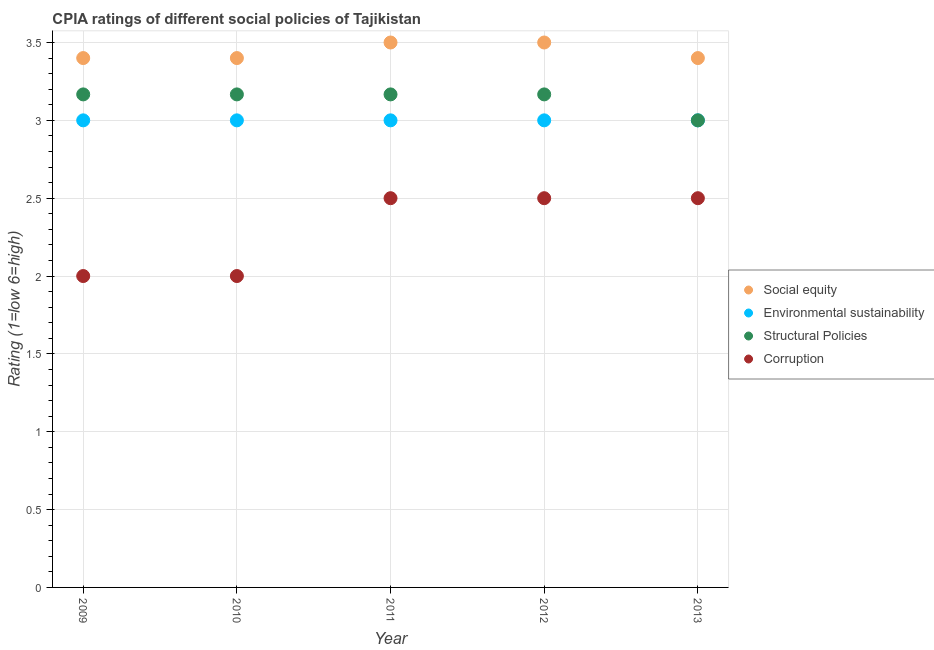How many different coloured dotlines are there?
Provide a succinct answer. 4. Is the number of dotlines equal to the number of legend labels?
Your answer should be very brief. Yes. What is the cpia rating of environmental sustainability in 2012?
Your response must be concise. 3. Across all years, what is the maximum cpia rating of structural policies?
Ensure brevity in your answer.  3.17. In which year was the cpia rating of corruption maximum?
Your response must be concise. 2011. What is the total cpia rating of structural policies in the graph?
Offer a terse response. 15.67. What is the difference between the cpia rating of environmental sustainability in 2011 and that in 2012?
Offer a very short reply. 0. What is the difference between the cpia rating of environmental sustainability in 2011 and the cpia rating of structural policies in 2010?
Offer a very short reply. -0.17. What is the average cpia rating of social equity per year?
Provide a short and direct response. 3.44. In the year 2011, what is the difference between the cpia rating of structural policies and cpia rating of social equity?
Your response must be concise. -0.33. Is the difference between the cpia rating of social equity in 2011 and 2012 greater than the difference between the cpia rating of corruption in 2011 and 2012?
Your answer should be very brief. No. What is the difference between the highest and the lowest cpia rating of environmental sustainability?
Make the answer very short. 0. In how many years, is the cpia rating of social equity greater than the average cpia rating of social equity taken over all years?
Give a very brief answer. 2. Is it the case that in every year, the sum of the cpia rating of social equity and cpia rating of environmental sustainability is greater than the cpia rating of structural policies?
Provide a succinct answer. Yes. How many dotlines are there?
Provide a short and direct response. 4. How many years are there in the graph?
Keep it short and to the point. 5. Are the values on the major ticks of Y-axis written in scientific E-notation?
Ensure brevity in your answer.  No. Does the graph contain any zero values?
Offer a terse response. No. How many legend labels are there?
Keep it short and to the point. 4. How are the legend labels stacked?
Your response must be concise. Vertical. What is the title of the graph?
Provide a short and direct response. CPIA ratings of different social policies of Tajikistan. What is the label or title of the X-axis?
Ensure brevity in your answer.  Year. What is the Rating (1=low 6=high) of Social equity in 2009?
Ensure brevity in your answer.  3.4. What is the Rating (1=low 6=high) in Structural Policies in 2009?
Offer a very short reply. 3.17. What is the Rating (1=low 6=high) in Corruption in 2009?
Offer a terse response. 2. What is the Rating (1=low 6=high) in Structural Policies in 2010?
Your answer should be very brief. 3.17. What is the Rating (1=low 6=high) in Social equity in 2011?
Your answer should be compact. 3.5. What is the Rating (1=low 6=high) in Structural Policies in 2011?
Ensure brevity in your answer.  3.17. What is the Rating (1=low 6=high) in Social equity in 2012?
Make the answer very short. 3.5. What is the Rating (1=low 6=high) of Structural Policies in 2012?
Offer a terse response. 3.17. What is the Rating (1=low 6=high) in Corruption in 2013?
Offer a terse response. 2.5. Across all years, what is the maximum Rating (1=low 6=high) of Social equity?
Make the answer very short. 3.5. Across all years, what is the maximum Rating (1=low 6=high) of Structural Policies?
Your answer should be very brief. 3.17. Across all years, what is the maximum Rating (1=low 6=high) of Corruption?
Ensure brevity in your answer.  2.5. Across all years, what is the minimum Rating (1=low 6=high) of Social equity?
Keep it short and to the point. 3.4. Across all years, what is the minimum Rating (1=low 6=high) of Structural Policies?
Provide a short and direct response. 3. What is the total Rating (1=low 6=high) in Social equity in the graph?
Provide a short and direct response. 17.2. What is the total Rating (1=low 6=high) of Structural Policies in the graph?
Provide a succinct answer. 15.67. What is the total Rating (1=low 6=high) in Corruption in the graph?
Ensure brevity in your answer.  11.5. What is the difference between the Rating (1=low 6=high) of Social equity in 2009 and that in 2010?
Offer a terse response. 0. What is the difference between the Rating (1=low 6=high) of Environmental sustainability in 2009 and that in 2010?
Your response must be concise. 0. What is the difference between the Rating (1=low 6=high) in Structural Policies in 2009 and that in 2010?
Provide a short and direct response. 0. What is the difference between the Rating (1=low 6=high) of Social equity in 2009 and that in 2011?
Keep it short and to the point. -0.1. What is the difference between the Rating (1=low 6=high) of Environmental sustainability in 2009 and that in 2011?
Your answer should be very brief. 0. What is the difference between the Rating (1=low 6=high) in Structural Policies in 2009 and that in 2011?
Offer a very short reply. 0. What is the difference between the Rating (1=low 6=high) of Corruption in 2009 and that in 2011?
Offer a terse response. -0.5. What is the difference between the Rating (1=low 6=high) of Social equity in 2009 and that in 2012?
Your answer should be compact. -0.1. What is the difference between the Rating (1=low 6=high) in Structural Policies in 2009 and that in 2012?
Ensure brevity in your answer.  0. What is the difference between the Rating (1=low 6=high) of Social equity in 2009 and that in 2013?
Your answer should be compact. 0. What is the difference between the Rating (1=low 6=high) in Environmental sustainability in 2009 and that in 2013?
Offer a very short reply. 0. What is the difference between the Rating (1=low 6=high) in Structural Policies in 2010 and that in 2011?
Your answer should be compact. 0. What is the difference between the Rating (1=low 6=high) in Social equity in 2010 and that in 2012?
Offer a terse response. -0.1. What is the difference between the Rating (1=low 6=high) of Environmental sustainability in 2010 and that in 2012?
Your answer should be compact. 0. What is the difference between the Rating (1=low 6=high) of Corruption in 2010 and that in 2012?
Offer a very short reply. -0.5. What is the difference between the Rating (1=low 6=high) in Social equity in 2010 and that in 2013?
Your answer should be compact. 0. What is the difference between the Rating (1=low 6=high) in Corruption in 2010 and that in 2013?
Give a very brief answer. -0.5. What is the difference between the Rating (1=low 6=high) in Social equity in 2011 and that in 2012?
Provide a succinct answer. 0. What is the difference between the Rating (1=low 6=high) of Environmental sustainability in 2011 and that in 2012?
Provide a succinct answer. 0. What is the difference between the Rating (1=low 6=high) in Structural Policies in 2011 and that in 2012?
Give a very brief answer. 0. What is the difference between the Rating (1=low 6=high) of Social equity in 2011 and that in 2013?
Offer a very short reply. 0.1. What is the difference between the Rating (1=low 6=high) of Structural Policies in 2011 and that in 2013?
Make the answer very short. 0.17. What is the difference between the Rating (1=low 6=high) in Social equity in 2012 and that in 2013?
Offer a very short reply. 0.1. What is the difference between the Rating (1=low 6=high) in Environmental sustainability in 2012 and that in 2013?
Make the answer very short. 0. What is the difference between the Rating (1=low 6=high) in Corruption in 2012 and that in 2013?
Your answer should be compact. 0. What is the difference between the Rating (1=low 6=high) in Social equity in 2009 and the Rating (1=low 6=high) in Structural Policies in 2010?
Offer a terse response. 0.23. What is the difference between the Rating (1=low 6=high) in Environmental sustainability in 2009 and the Rating (1=low 6=high) in Structural Policies in 2010?
Provide a succinct answer. -0.17. What is the difference between the Rating (1=low 6=high) of Structural Policies in 2009 and the Rating (1=low 6=high) of Corruption in 2010?
Make the answer very short. 1.17. What is the difference between the Rating (1=low 6=high) in Social equity in 2009 and the Rating (1=low 6=high) in Structural Policies in 2011?
Your answer should be compact. 0.23. What is the difference between the Rating (1=low 6=high) in Social equity in 2009 and the Rating (1=low 6=high) in Corruption in 2011?
Provide a succinct answer. 0.9. What is the difference between the Rating (1=low 6=high) in Environmental sustainability in 2009 and the Rating (1=low 6=high) in Corruption in 2011?
Give a very brief answer. 0.5. What is the difference between the Rating (1=low 6=high) in Social equity in 2009 and the Rating (1=low 6=high) in Structural Policies in 2012?
Make the answer very short. 0.23. What is the difference between the Rating (1=low 6=high) in Social equity in 2009 and the Rating (1=low 6=high) in Corruption in 2012?
Make the answer very short. 0.9. What is the difference between the Rating (1=low 6=high) in Social equity in 2009 and the Rating (1=low 6=high) in Environmental sustainability in 2013?
Your response must be concise. 0.4. What is the difference between the Rating (1=low 6=high) in Social equity in 2009 and the Rating (1=low 6=high) in Structural Policies in 2013?
Your response must be concise. 0.4. What is the difference between the Rating (1=low 6=high) in Environmental sustainability in 2009 and the Rating (1=low 6=high) in Structural Policies in 2013?
Your response must be concise. 0. What is the difference between the Rating (1=low 6=high) in Structural Policies in 2009 and the Rating (1=low 6=high) in Corruption in 2013?
Make the answer very short. 0.67. What is the difference between the Rating (1=low 6=high) in Social equity in 2010 and the Rating (1=low 6=high) in Structural Policies in 2011?
Ensure brevity in your answer.  0.23. What is the difference between the Rating (1=low 6=high) of Environmental sustainability in 2010 and the Rating (1=low 6=high) of Structural Policies in 2011?
Make the answer very short. -0.17. What is the difference between the Rating (1=low 6=high) of Structural Policies in 2010 and the Rating (1=low 6=high) of Corruption in 2011?
Ensure brevity in your answer.  0.67. What is the difference between the Rating (1=low 6=high) of Social equity in 2010 and the Rating (1=low 6=high) of Environmental sustainability in 2012?
Offer a very short reply. 0.4. What is the difference between the Rating (1=low 6=high) of Social equity in 2010 and the Rating (1=low 6=high) of Structural Policies in 2012?
Your response must be concise. 0.23. What is the difference between the Rating (1=low 6=high) of Environmental sustainability in 2010 and the Rating (1=low 6=high) of Structural Policies in 2012?
Make the answer very short. -0.17. What is the difference between the Rating (1=low 6=high) of Structural Policies in 2010 and the Rating (1=low 6=high) of Corruption in 2012?
Provide a succinct answer. 0.67. What is the difference between the Rating (1=low 6=high) in Environmental sustainability in 2010 and the Rating (1=low 6=high) in Corruption in 2013?
Your answer should be very brief. 0.5. What is the difference between the Rating (1=low 6=high) in Structural Policies in 2010 and the Rating (1=low 6=high) in Corruption in 2013?
Give a very brief answer. 0.67. What is the difference between the Rating (1=low 6=high) in Social equity in 2011 and the Rating (1=low 6=high) in Environmental sustainability in 2012?
Provide a succinct answer. 0.5. What is the difference between the Rating (1=low 6=high) in Social equity in 2011 and the Rating (1=low 6=high) in Corruption in 2012?
Give a very brief answer. 1. What is the difference between the Rating (1=low 6=high) of Environmental sustainability in 2011 and the Rating (1=low 6=high) of Structural Policies in 2012?
Your answer should be very brief. -0.17. What is the difference between the Rating (1=low 6=high) of Environmental sustainability in 2011 and the Rating (1=low 6=high) of Corruption in 2012?
Offer a very short reply. 0.5. What is the difference between the Rating (1=low 6=high) in Social equity in 2011 and the Rating (1=low 6=high) in Environmental sustainability in 2013?
Make the answer very short. 0.5. What is the difference between the Rating (1=low 6=high) in Environmental sustainability in 2011 and the Rating (1=low 6=high) in Structural Policies in 2013?
Make the answer very short. 0. What is the difference between the Rating (1=low 6=high) in Environmental sustainability in 2011 and the Rating (1=low 6=high) in Corruption in 2013?
Your response must be concise. 0.5. What is the difference between the Rating (1=low 6=high) of Social equity in 2012 and the Rating (1=low 6=high) of Environmental sustainability in 2013?
Provide a short and direct response. 0.5. What is the difference between the Rating (1=low 6=high) of Social equity in 2012 and the Rating (1=low 6=high) of Structural Policies in 2013?
Your answer should be compact. 0.5. What is the difference between the Rating (1=low 6=high) in Social equity in 2012 and the Rating (1=low 6=high) in Corruption in 2013?
Your response must be concise. 1. What is the difference between the Rating (1=low 6=high) of Environmental sustainability in 2012 and the Rating (1=low 6=high) of Corruption in 2013?
Provide a succinct answer. 0.5. What is the average Rating (1=low 6=high) of Social equity per year?
Keep it short and to the point. 3.44. What is the average Rating (1=low 6=high) of Structural Policies per year?
Your answer should be compact. 3.13. What is the average Rating (1=low 6=high) of Corruption per year?
Offer a very short reply. 2.3. In the year 2009, what is the difference between the Rating (1=low 6=high) in Social equity and Rating (1=low 6=high) in Structural Policies?
Your answer should be compact. 0.23. In the year 2009, what is the difference between the Rating (1=low 6=high) in Social equity and Rating (1=low 6=high) in Corruption?
Make the answer very short. 1.4. In the year 2009, what is the difference between the Rating (1=low 6=high) in Environmental sustainability and Rating (1=low 6=high) in Corruption?
Your answer should be compact. 1. In the year 2009, what is the difference between the Rating (1=low 6=high) in Structural Policies and Rating (1=low 6=high) in Corruption?
Offer a terse response. 1.17. In the year 2010, what is the difference between the Rating (1=low 6=high) in Social equity and Rating (1=low 6=high) in Environmental sustainability?
Give a very brief answer. 0.4. In the year 2010, what is the difference between the Rating (1=low 6=high) of Social equity and Rating (1=low 6=high) of Structural Policies?
Keep it short and to the point. 0.23. In the year 2010, what is the difference between the Rating (1=low 6=high) of Social equity and Rating (1=low 6=high) of Corruption?
Make the answer very short. 1.4. In the year 2010, what is the difference between the Rating (1=low 6=high) of Environmental sustainability and Rating (1=low 6=high) of Structural Policies?
Offer a very short reply. -0.17. In the year 2011, what is the difference between the Rating (1=low 6=high) of Social equity and Rating (1=low 6=high) of Corruption?
Give a very brief answer. 1. In the year 2011, what is the difference between the Rating (1=low 6=high) in Environmental sustainability and Rating (1=low 6=high) in Structural Policies?
Provide a short and direct response. -0.17. In the year 2011, what is the difference between the Rating (1=low 6=high) in Environmental sustainability and Rating (1=low 6=high) in Corruption?
Keep it short and to the point. 0.5. In the year 2011, what is the difference between the Rating (1=low 6=high) in Structural Policies and Rating (1=low 6=high) in Corruption?
Your response must be concise. 0.67. In the year 2012, what is the difference between the Rating (1=low 6=high) of Environmental sustainability and Rating (1=low 6=high) of Structural Policies?
Keep it short and to the point. -0.17. In the year 2012, what is the difference between the Rating (1=low 6=high) of Environmental sustainability and Rating (1=low 6=high) of Corruption?
Give a very brief answer. 0.5. In the year 2013, what is the difference between the Rating (1=low 6=high) in Social equity and Rating (1=low 6=high) in Environmental sustainability?
Provide a succinct answer. 0.4. In the year 2013, what is the difference between the Rating (1=low 6=high) of Social equity and Rating (1=low 6=high) of Structural Policies?
Provide a succinct answer. 0.4. In the year 2013, what is the difference between the Rating (1=low 6=high) of Social equity and Rating (1=low 6=high) of Corruption?
Provide a succinct answer. 0.9. In the year 2013, what is the difference between the Rating (1=low 6=high) of Environmental sustainability and Rating (1=low 6=high) of Structural Policies?
Provide a short and direct response. 0. In the year 2013, what is the difference between the Rating (1=low 6=high) of Structural Policies and Rating (1=low 6=high) of Corruption?
Give a very brief answer. 0.5. What is the ratio of the Rating (1=low 6=high) of Environmental sustainability in 2009 to that in 2010?
Provide a succinct answer. 1. What is the ratio of the Rating (1=low 6=high) in Social equity in 2009 to that in 2011?
Make the answer very short. 0.97. What is the ratio of the Rating (1=low 6=high) of Environmental sustainability in 2009 to that in 2011?
Keep it short and to the point. 1. What is the ratio of the Rating (1=low 6=high) of Structural Policies in 2009 to that in 2011?
Offer a terse response. 1. What is the ratio of the Rating (1=low 6=high) of Corruption in 2009 to that in 2011?
Provide a succinct answer. 0.8. What is the ratio of the Rating (1=low 6=high) of Social equity in 2009 to that in 2012?
Your response must be concise. 0.97. What is the ratio of the Rating (1=low 6=high) in Environmental sustainability in 2009 to that in 2012?
Provide a short and direct response. 1. What is the ratio of the Rating (1=low 6=high) in Structural Policies in 2009 to that in 2013?
Provide a succinct answer. 1.06. What is the ratio of the Rating (1=low 6=high) of Social equity in 2010 to that in 2011?
Keep it short and to the point. 0.97. What is the ratio of the Rating (1=low 6=high) in Structural Policies in 2010 to that in 2011?
Your response must be concise. 1. What is the ratio of the Rating (1=low 6=high) in Corruption in 2010 to that in 2011?
Provide a succinct answer. 0.8. What is the ratio of the Rating (1=low 6=high) of Social equity in 2010 to that in 2012?
Provide a short and direct response. 0.97. What is the ratio of the Rating (1=low 6=high) of Environmental sustainability in 2010 to that in 2012?
Ensure brevity in your answer.  1. What is the ratio of the Rating (1=low 6=high) of Structural Policies in 2010 to that in 2012?
Make the answer very short. 1. What is the ratio of the Rating (1=low 6=high) of Corruption in 2010 to that in 2012?
Provide a succinct answer. 0.8. What is the ratio of the Rating (1=low 6=high) of Environmental sustainability in 2010 to that in 2013?
Your answer should be very brief. 1. What is the ratio of the Rating (1=low 6=high) of Structural Policies in 2010 to that in 2013?
Ensure brevity in your answer.  1.06. What is the ratio of the Rating (1=low 6=high) in Corruption in 2011 to that in 2012?
Keep it short and to the point. 1. What is the ratio of the Rating (1=low 6=high) of Social equity in 2011 to that in 2013?
Provide a short and direct response. 1.03. What is the ratio of the Rating (1=low 6=high) in Environmental sustainability in 2011 to that in 2013?
Your response must be concise. 1. What is the ratio of the Rating (1=low 6=high) of Structural Policies in 2011 to that in 2013?
Keep it short and to the point. 1.06. What is the ratio of the Rating (1=low 6=high) in Corruption in 2011 to that in 2013?
Make the answer very short. 1. What is the ratio of the Rating (1=low 6=high) in Social equity in 2012 to that in 2013?
Offer a very short reply. 1.03. What is the ratio of the Rating (1=low 6=high) of Structural Policies in 2012 to that in 2013?
Keep it short and to the point. 1.06. What is the ratio of the Rating (1=low 6=high) of Corruption in 2012 to that in 2013?
Ensure brevity in your answer.  1. What is the difference between the highest and the second highest Rating (1=low 6=high) in Structural Policies?
Keep it short and to the point. 0. What is the difference between the highest and the lowest Rating (1=low 6=high) in Environmental sustainability?
Your response must be concise. 0. What is the difference between the highest and the lowest Rating (1=low 6=high) in Structural Policies?
Provide a succinct answer. 0.17. What is the difference between the highest and the lowest Rating (1=low 6=high) in Corruption?
Your answer should be compact. 0.5. 